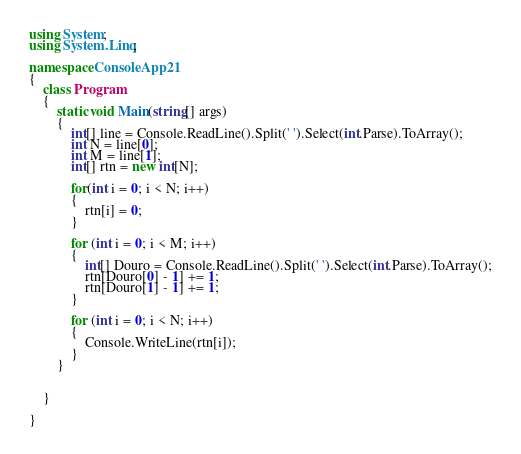<code> <loc_0><loc_0><loc_500><loc_500><_C#_>using System;
using System.Linq;

namespace ConsoleApp21
{
    class Program
    {
        static void Main(string[] args)
        {
            int[] line = Console.ReadLine().Split(' ').Select(int.Parse).ToArray();
            int N = line[0];
            int M = line[1];
            int[] rtn = new int[N];

            for(int i = 0; i < N; i++)
            {
                rtn[i] = 0;
            }

            for (int i = 0; i < M; i++)
            {
                int[] Douro = Console.ReadLine().Split(' ').Select(int.Parse).ToArray();
                rtn[Douro[0] - 1] += 1;
                rtn[Douro[1] - 1] += 1;
            }

            for (int i = 0; i < N; i++)
            {
                Console.WriteLine(rtn[i]);
            }
        }


    }

}
</code> 